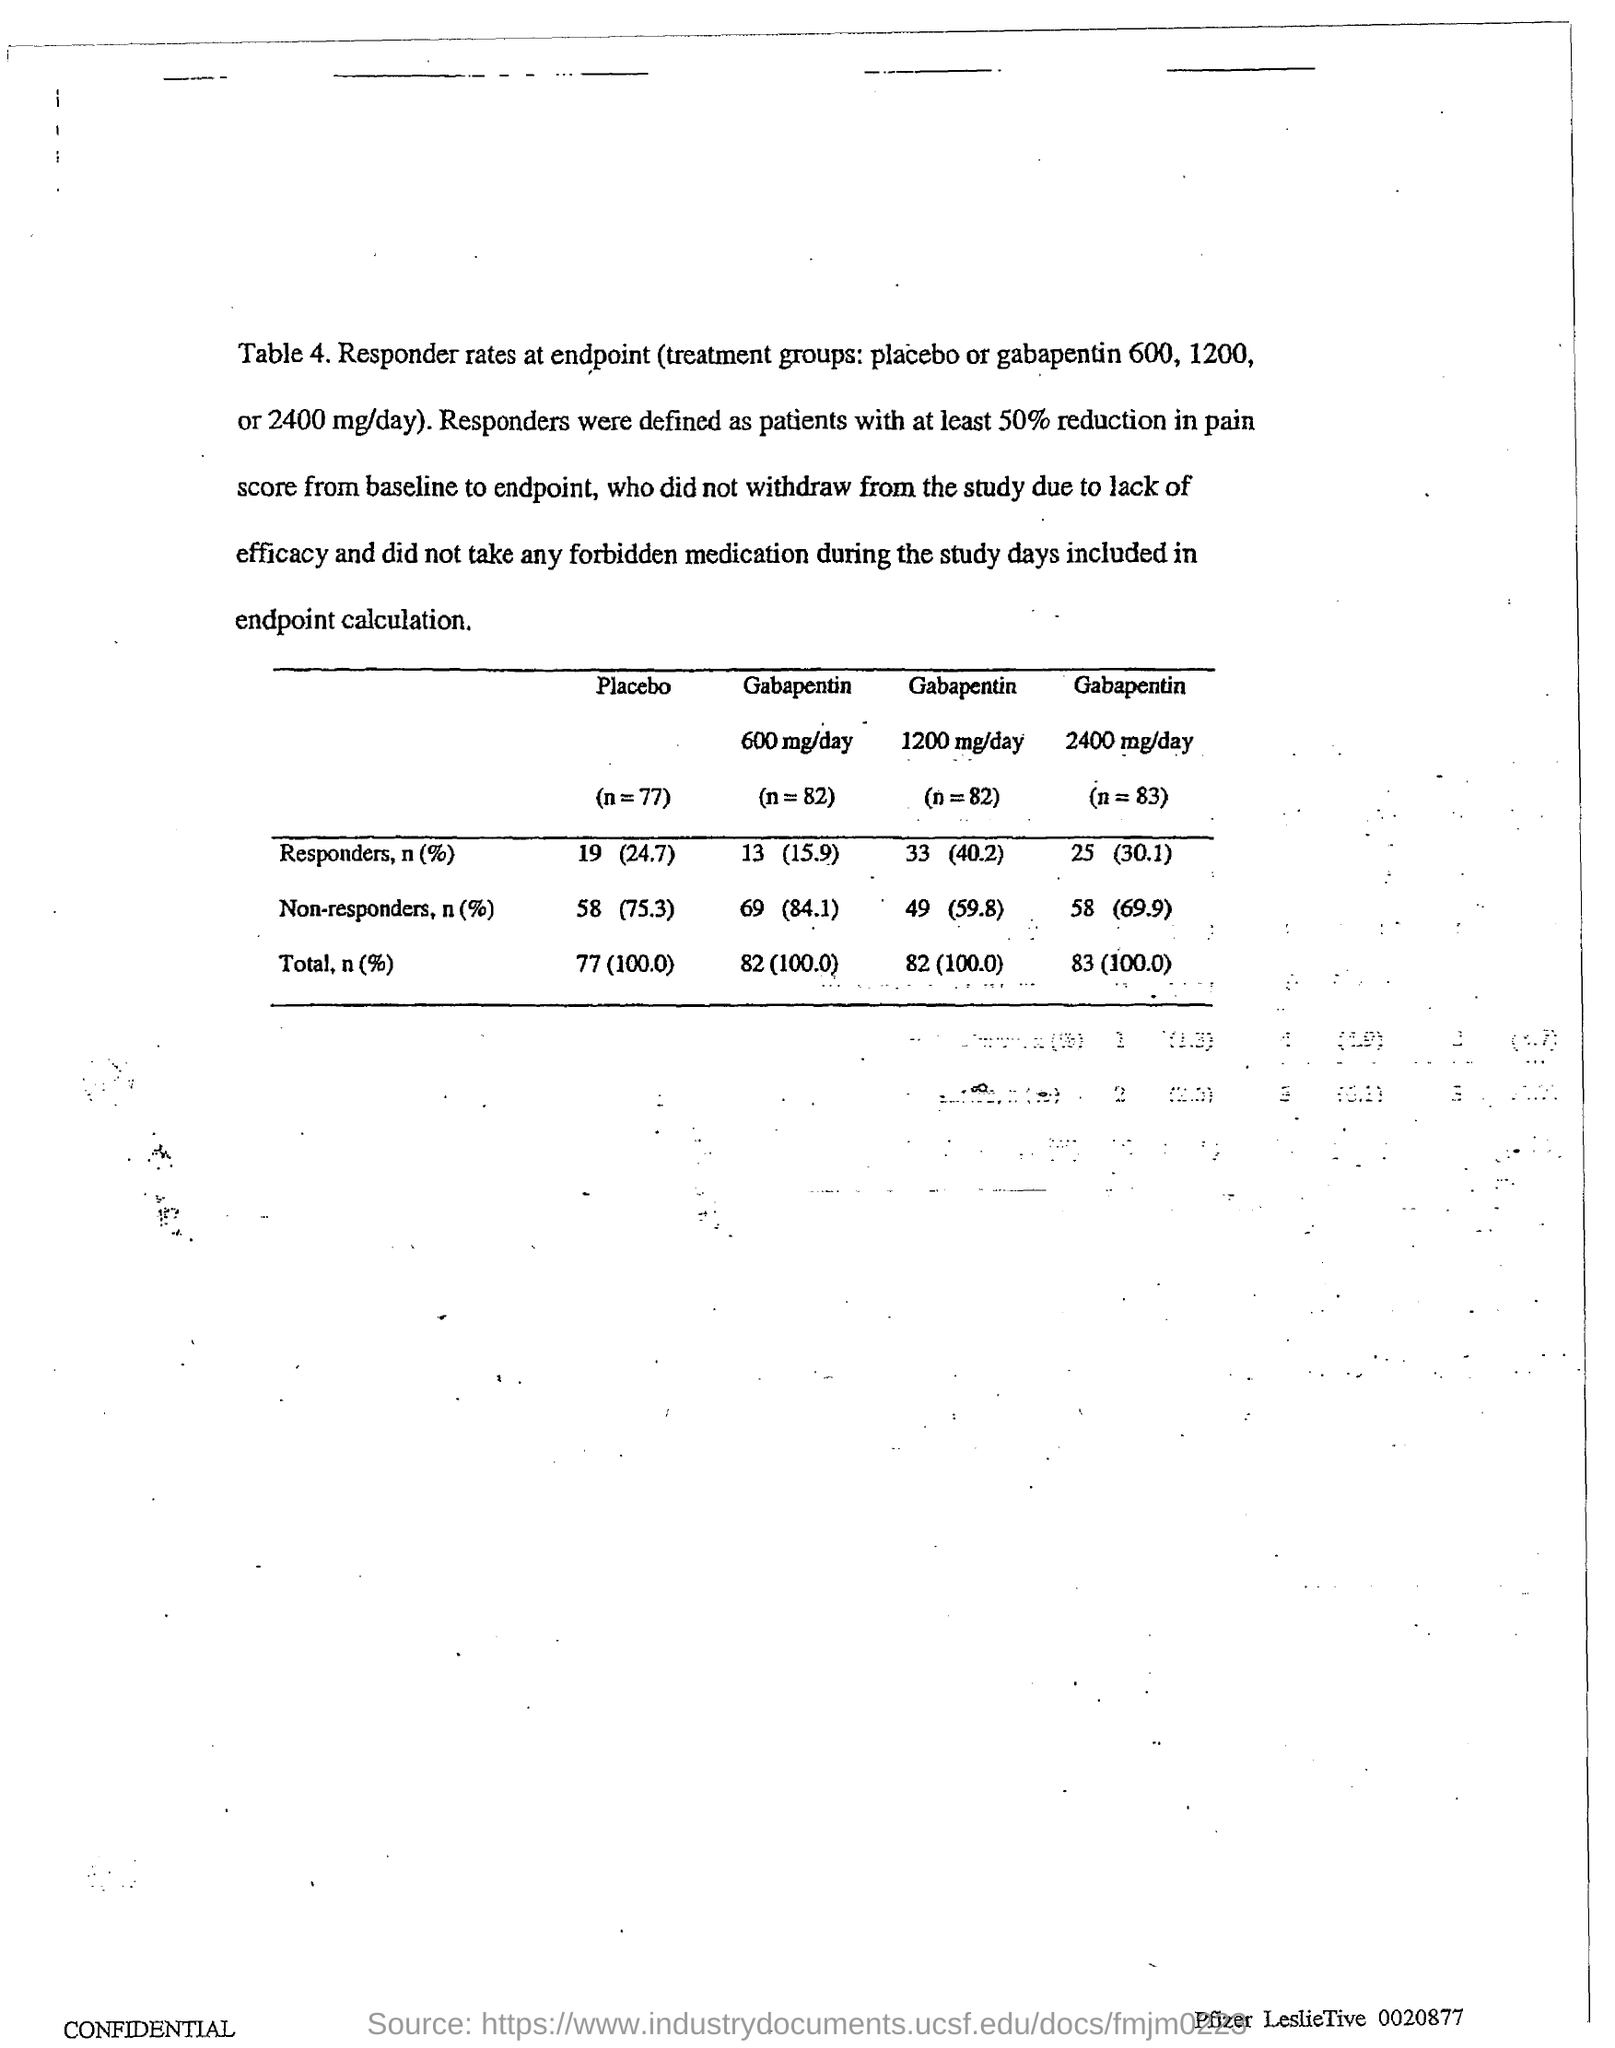Specify some key components in this picture. 84.1% of the patients who received gabapentin 600 mg/day did not respond to the treatment. The percentage of non-responders to gabapentin 2400 mg/day was 69.9%. The response rate in the placebo group was 19 patients (24.7%). The total is 82, and it represents 100.0%. 